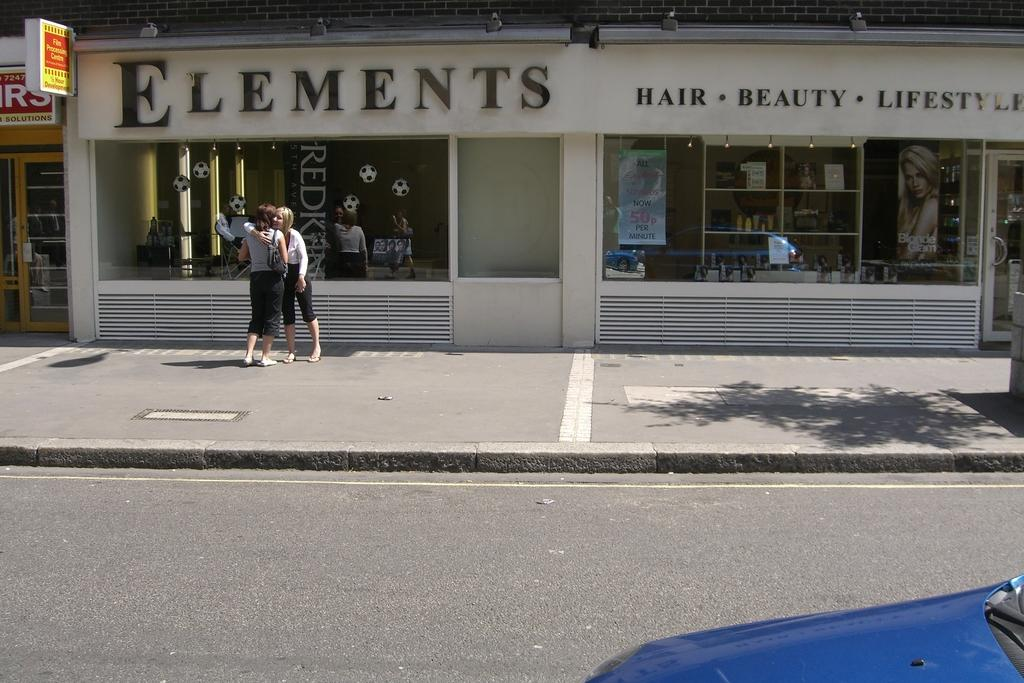<image>
Give a short and clear explanation of the subsequent image. A store front with the store name "Elements" on it with two women standing outside. 